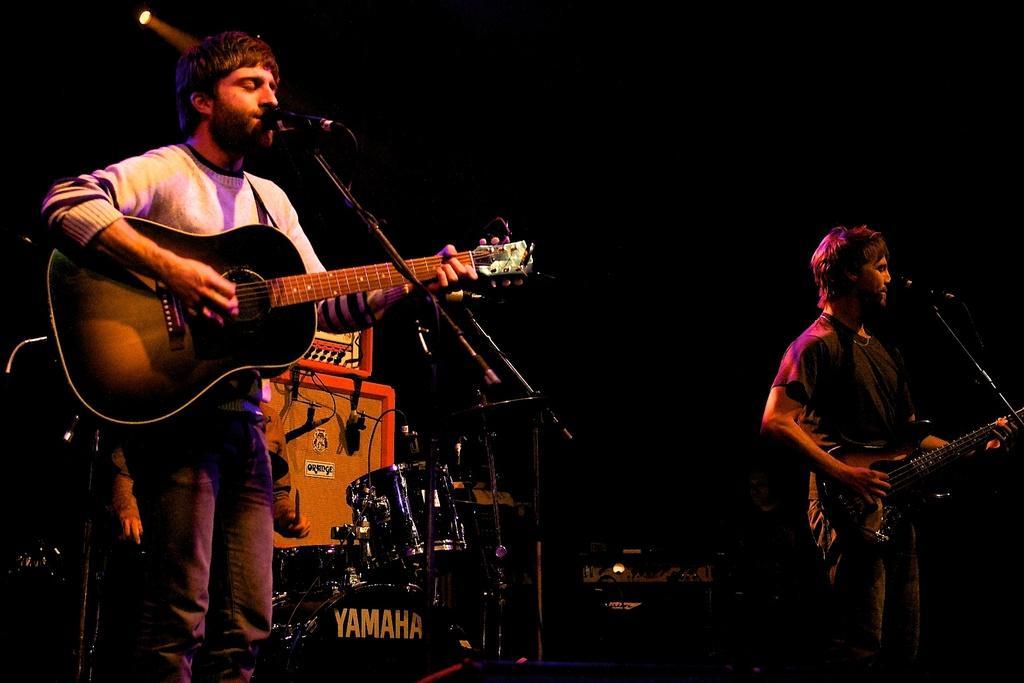In one or two sentences, can you explain what this image depicts? In this image I can see two persons standing and holding a guitar. There is a mic and a stand. At the back side there are some musical instruments. 